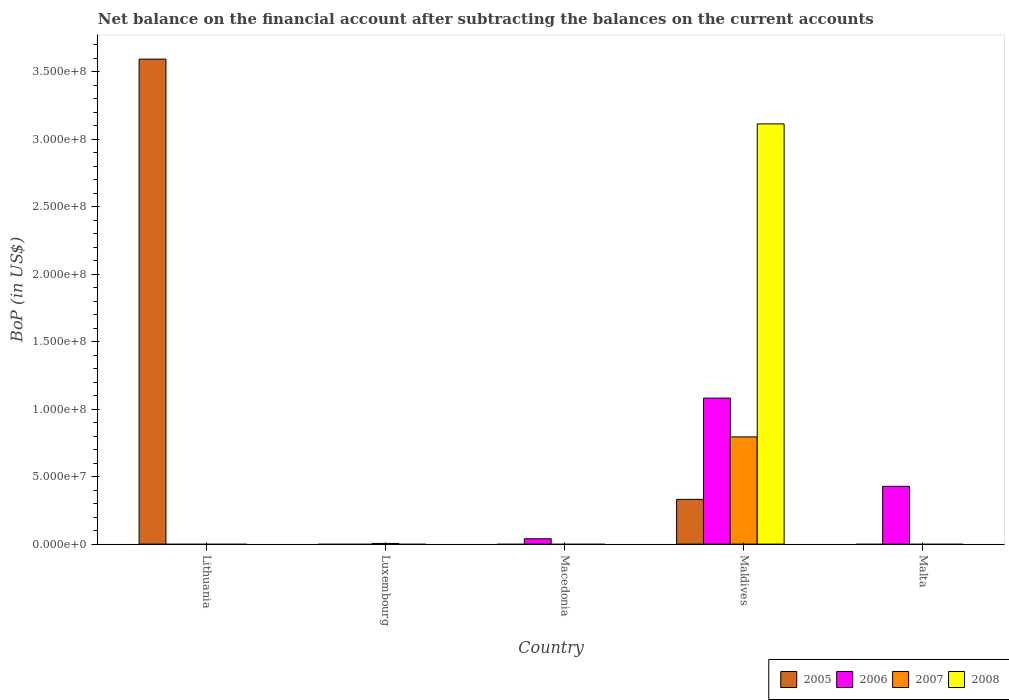How many bars are there on the 4th tick from the left?
Keep it short and to the point. 4. What is the label of the 4th group of bars from the left?
Ensure brevity in your answer.  Maldives. In how many cases, is the number of bars for a given country not equal to the number of legend labels?
Your answer should be compact. 4. What is the Balance of Payments in 2007 in Lithuania?
Ensure brevity in your answer.  0. Across all countries, what is the maximum Balance of Payments in 2008?
Offer a very short reply. 3.11e+08. Across all countries, what is the minimum Balance of Payments in 2006?
Your answer should be very brief. 0. In which country was the Balance of Payments in 2005 maximum?
Give a very brief answer. Lithuania. What is the total Balance of Payments in 2006 in the graph?
Give a very brief answer. 1.55e+08. What is the difference between the Balance of Payments in 2006 in Maldives and that in Malta?
Your answer should be compact. 6.54e+07. What is the average Balance of Payments in 2005 per country?
Make the answer very short. 7.85e+07. What is the difference between the Balance of Payments of/in 2006 and Balance of Payments of/in 2005 in Maldives?
Your response must be concise. 7.51e+07. What is the difference between the highest and the second highest Balance of Payments in 2006?
Your answer should be very brief. 3.89e+07. What is the difference between the highest and the lowest Balance of Payments in 2005?
Offer a terse response. 3.60e+08. Is the sum of the Balance of Payments in 2006 in Macedonia and Malta greater than the maximum Balance of Payments in 2007 across all countries?
Provide a succinct answer. No. Is it the case that in every country, the sum of the Balance of Payments in 2007 and Balance of Payments in 2006 is greater than the Balance of Payments in 2008?
Your answer should be very brief. No. How many bars are there?
Offer a very short reply. 8. Are the values on the major ticks of Y-axis written in scientific E-notation?
Make the answer very short. Yes. Does the graph contain any zero values?
Provide a short and direct response. Yes. Where does the legend appear in the graph?
Your response must be concise. Bottom right. How are the legend labels stacked?
Provide a succinct answer. Horizontal. What is the title of the graph?
Provide a short and direct response. Net balance on the financial account after subtracting the balances on the current accounts. Does "1987" appear as one of the legend labels in the graph?
Your answer should be very brief. No. What is the label or title of the X-axis?
Your response must be concise. Country. What is the label or title of the Y-axis?
Provide a short and direct response. BoP (in US$). What is the BoP (in US$) of 2005 in Lithuania?
Offer a terse response. 3.60e+08. What is the BoP (in US$) in 2007 in Lithuania?
Your answer should be compact. 0. What is the BoP (in US$) in 2008 in Lithuania?
Provide a short and direct response. 0. What is the BoP (in US$) in 2005 in Luxembourg?
Provide a short and direct response. 0. What is the BoP (in US$) of 2007 in Luxembourg?
Offer a terse response. 4.90e+05. What is the BoP (in US$) in 2006 in Macedonia?
Provide a succinct answer. 3.96e+06. What is the BoP (in US$) of 2007 in Macedonia?
Your response must be concise. 0. What is the BoP (in US$) in 2008 in Macedonia?
Ensure brevity in your answer.  0. What is the BoP (in US$) in 2005 in Maldives?
Ensure brevity in your answer.  3.32e+07. What is the BoP (in US$) of 2006 in Maldives?
Ensure brevity in your answer.  1.08e+08. What is the BoP (in US$) of 2007 in Maldives?
Your answer should be compact. 7.95e+07. What is the BoP (in US$) in 2008 in Maldives?
Make the answer very short. 3.11e+08. What is the BoP (in US$) in 2006 in Malta?
Give a very brief answer. 4.28e+07. What is the BoP (in US$) of 2008 in Malta?
Your answer should be compact. 0. Across all countries, what is the maximum BoP (in US$) of 2005?
Your answer should be compact. 3.60e+08. Across all countries, what is the maximum BoP (in US$) in 2006?
Ensure brevity in your answer.  1.08e+08. Across all countries, what is the maximum BoP (in US$) of 2007?
Your answer should be compact. 7.95e+07. Across all countries, what is the maximum BoP (in US$) of 2008?
Your answer should be very brief. 3.11e+08. Across all countries, what is the minimum BoP (in US$) in 2007?
Make the answer very short. 0. Across all countries, what is the minimum BoP (in US$) of 2008?
Your response must be concise. 0. What is the total BoP (in US$) of 2005 in the graph?
Your response must be concise. 3.93e+08. What is the total BoP (in US$) of 2006 in the graph?
Your answer should be very brief. 1.55e+08. What is the total BoP (in US$) of 2007 in the graph?
Provide a succinct answer. 8.00e+07. What is the total BoP (in US$) of 2008 in the graph?
Offer a terse response. 3.11e+08. What is the difference between the BoP (in US$) of 2005 in Lithuania and that in Maldives?
Offer a terse response. 3.26e+08. What is the difference between the BoP (in US$) of 2007 in Luxembourg and that in Maldives?
Your response must be concise. -7.90e+07. What is the difference between the BoP (in US$) in 2006 in Macedonia and that in Maldives?
Provide a short and direct response. -1.04e+08. What is the difference between the BoP (in US$) in 2006 in Macedonia and that in Malta?
Give a very brief answer. -3.89e+07. What is the difference between the BoP (in US$) in 2006 in Maldives and that in Malta?
Provide a short and direct response. 6.54e+07. What is the difference between the BoP (in US$) in 2005 in Lithuania and the BoP (in US$) in 2007 in Luxembourg?
Offer a very short reply. 3.59e+08. What is the difference between the BoP (in US$) in 2005 in Lithuania and the BoP (in US$) in 2006 in Macedonia?
Keep it short and to the point. 3.56e+08. What is the difference between the BoP (in US$) of 2005 in Lithuania and the BoP (in US$) of 2006 in Maldives?
Provide a short and direct response. 2.51e+08. What is the difference between the BoP (in US$) in 2005 in Lithuania and the BoP (in US$) in 2007 in Maldives?
Your answer should be very brief. 2.80e+08. What is the difference between the BoP (in US$) of 2005 in Lithuania and the BoP (in US$) of 2008 in Maldives?
Keep it short and to the point. 4.80e+07. What is the difference between the BoP (in US$) of 2005 in Lithuania and the BoP (in US$) of 2006 in Malta?
Make the answer very short. 3.17e+08. What is the difference between the BoP (in US$) of 2007 in Luxembourg and the BoP (in US$) of 2008 in Maldives?
Offer a very short reply. -3.11e+08. What is the difference between the BoP (in US$) in 2006 in Macedonia and the BoP (in US$) in 2007 in Maldives?
Your response must be concise. -7.55e+07. What is the difference between the BoP (in US$) of 2006 in Macedonia and the BoP (in US$) of 2008 in Maldives?
Offer a very short reply. -3.08e+08. What is the difference between the BoP (in US$) in 2005 in Maldives and the BoP (in US$) in 2006 in Malta?
Make the answer very short. -9.65e+06. What is the average BoP (in US$) in 2005 per country?
Offer a terse response. 7.85e+07. What is the average BoP (in US$) in 2006 per country?
Ensure brevity in your answer.  3.10e+07. What is the average BoP (in US$) in 2007 per country?
Provide a short and direct response. 1.60e+07. What is the average BoP (in US$) in 2008 per country?
Your response must be concise. 6.23e+07. What is the difference between the BoP (in US$) in 2005 and BoP (in US$) in 2006 in Maldives?
Your response must be concise. -7.51e+07. What is the difference between the BoP (in US$) in 2005 and BoP (in US$) in 2007 in Maldives?
Your response must be concise. -4.63e+07. What is the difference between the BoP (in US$) in 2005 and BoP (in US$) in 2008 in Maldives?
Offer a very short reply. -2.78e+08. What is the difference between the BoP (in US$) of 2006 and BoP (in US$) of 2007 in Maldives?
Ensure brevity in your answer.  2.88e+07. What is the difference between the BoP (in US$) in 2006 and BoP (in US$) in 2008 in Maldives?
Give a very brief answer. -2.03e+08. What is the difference between the BoP (in US$) in 2007 and BoP (in US$) in 2008 in Maldives?
Provide a succinct answer. -2.32e+08. What is the ratio of the BoP (in US$) of 2005 in Lithuania to that in Maldives?
Provide a succinct answer. 10.84. What is the ratio of the BoP (in US$) in 2007 in Luxembourg to that in Maldives?
Your response must be concise. 0.01. What is the ratio of the BoP (in US$) in 2006 in Macedonia to that in Maldives?
Give a very brief answer. 0.04. What is the ratio of the BoP (in US$) in 2006 in Macedonia to that in Malta?
Provide a succinct answer. 0.09. What is the ratio of the BoP (in US$) of 2006 in Maldives to that in Malta?
Give a very brief answer. 2.53. What is the difference between the highest and the second highest BoP (in US$) in 2006?
Your answer should be compact. 6.54e+07. What is the difference between the highest and the lowest BoP (in US$) in 2005?
Your answer should be very brief. 3.60e+08. What is the difference between the highest and the lowest BoP (in US$) of 2006?
Make the answer very short. 1.08e+08. What is the difference between the highest and the lowest BoP (in US$) of 2007?
Offer a terse response. 7.95e+07. What is the difference between the highest and the lowest BoP (in US$) of 2008?
Ensure brevity in your answer.  3.11e+08. 